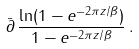<formula> <loc_0><loc_0><loc_500><loc_500>\bar { \partial } \, \frac { \ln ( 1 - e ^ { - 2 \pi z / \beta } ) } { 1 - e ^ { - 2 \pi z / \beta } } \, .</formula> 